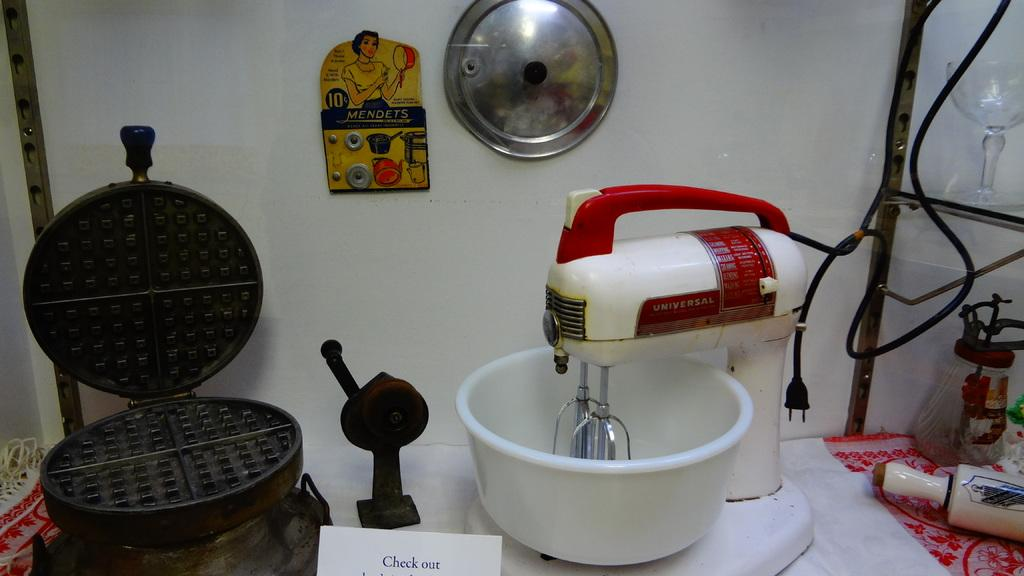<image>
Summarize the visual content of the image. an old waffle iron and UNIVERSAL mixer on display 